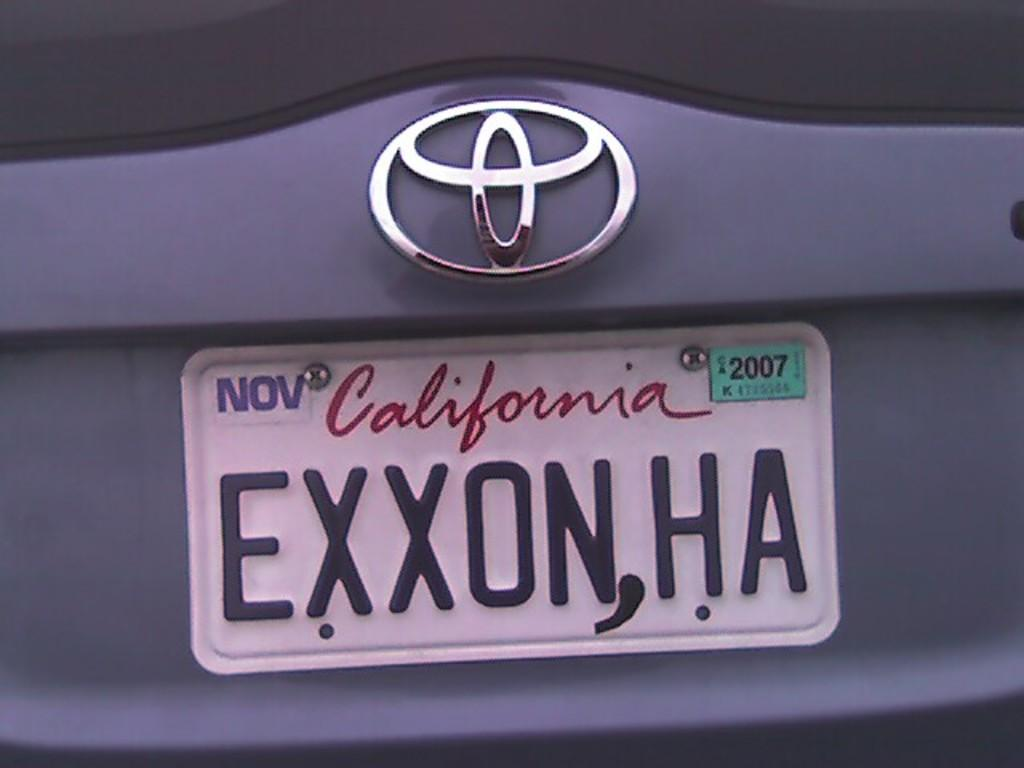<image>
Create a compact narrative representing the image presented. White California license plate which says EXXONHA on it. 